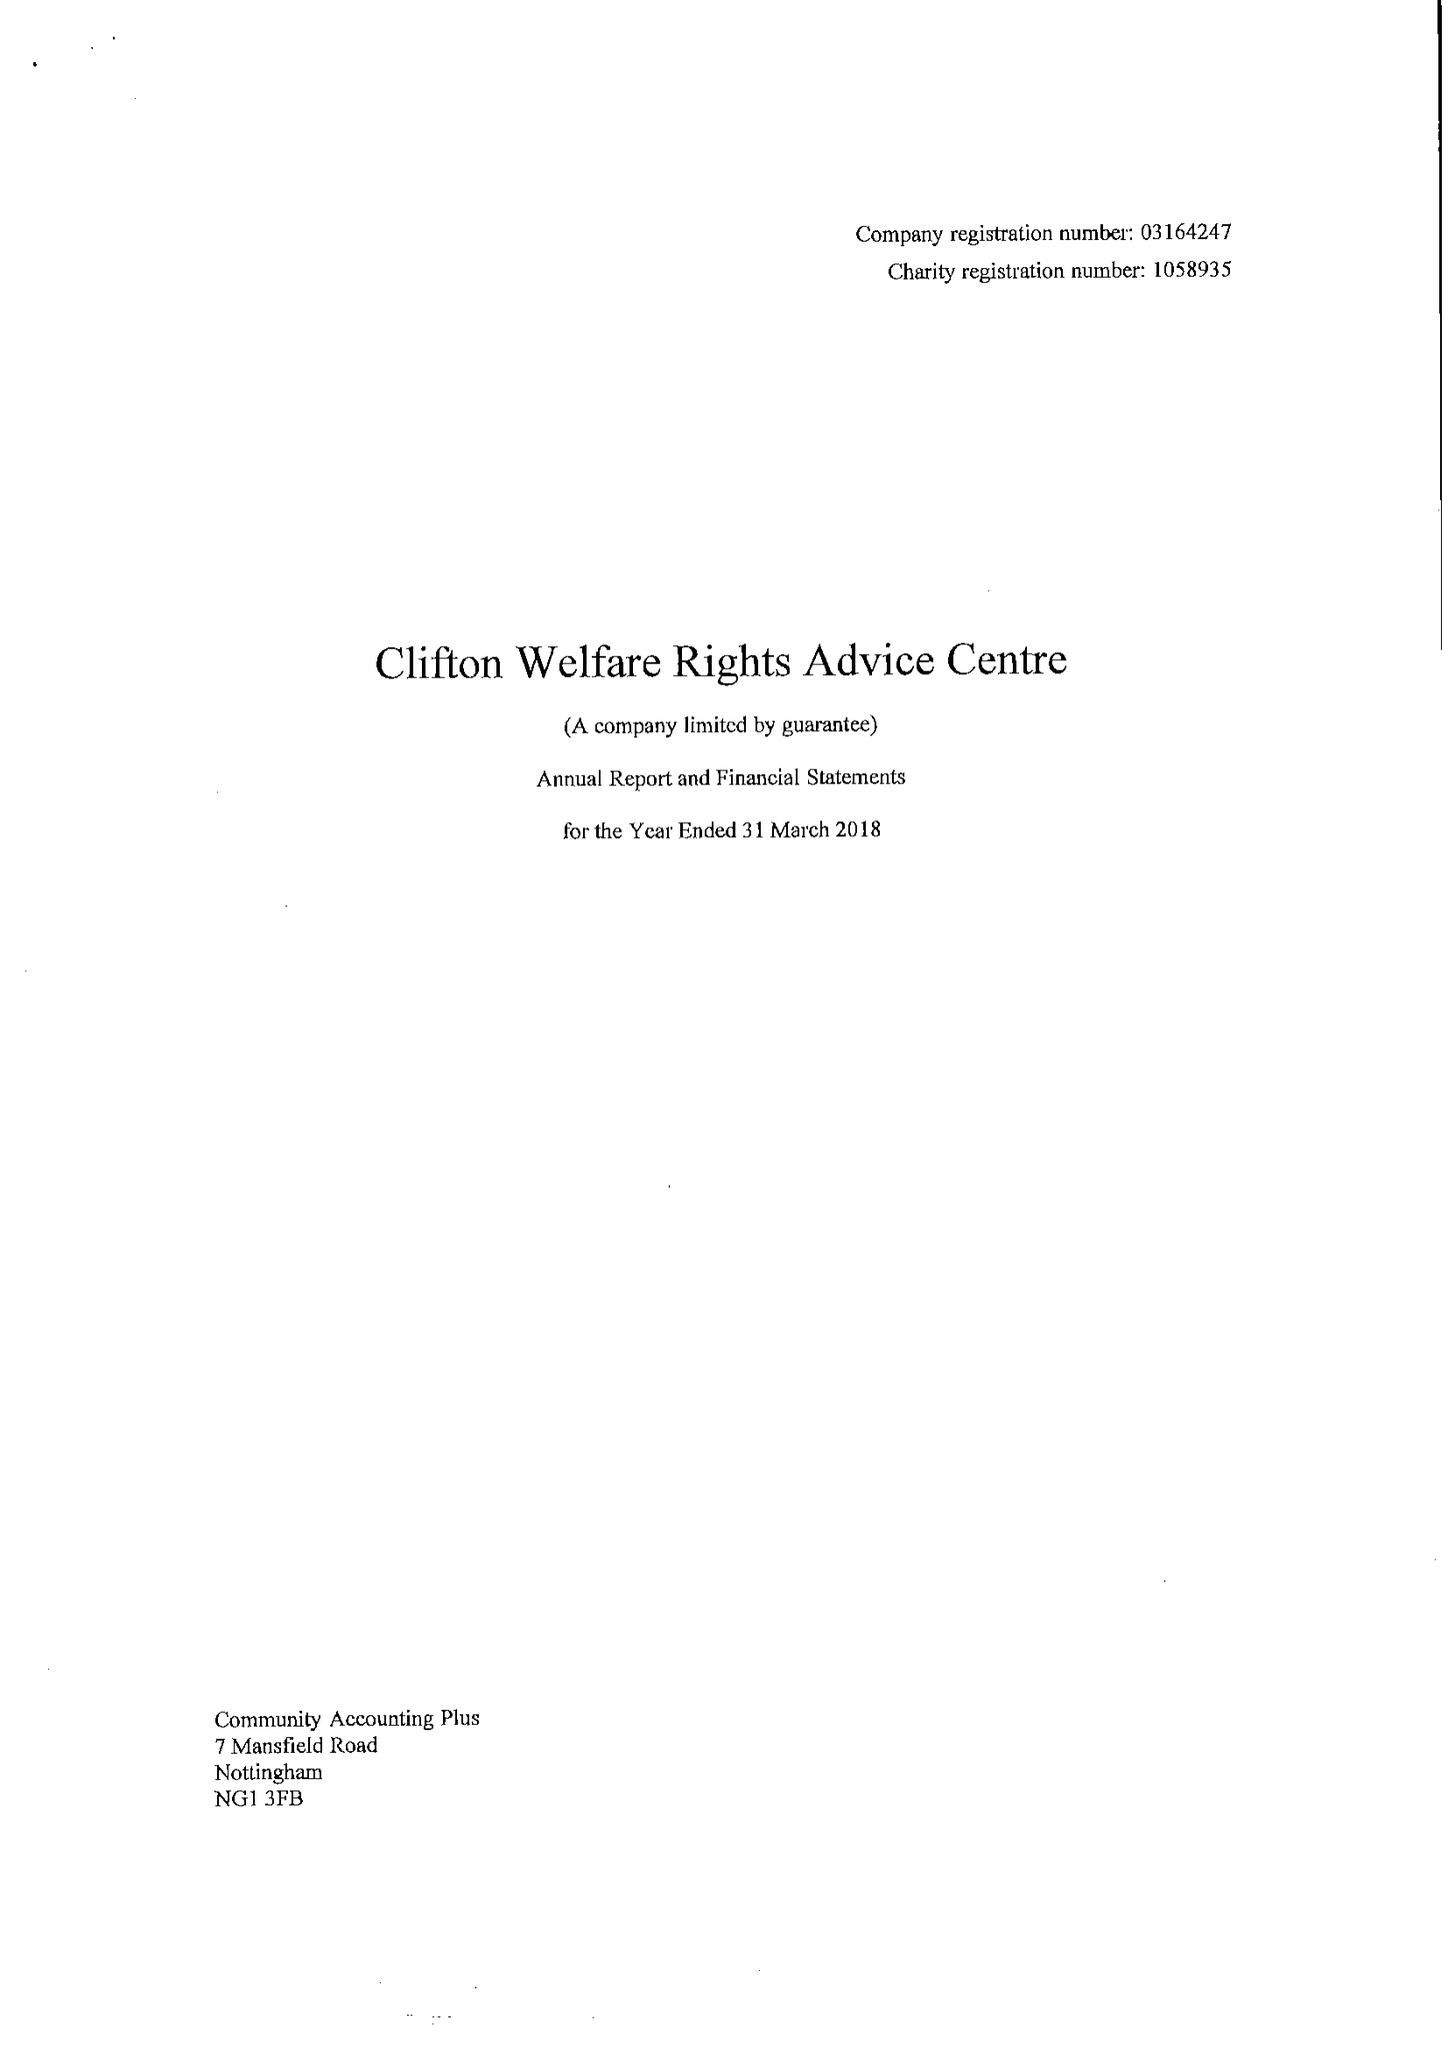What is the value for the spending_annually_in_british_pounds?
Answer the question using a single word or phrase. 74725.00 